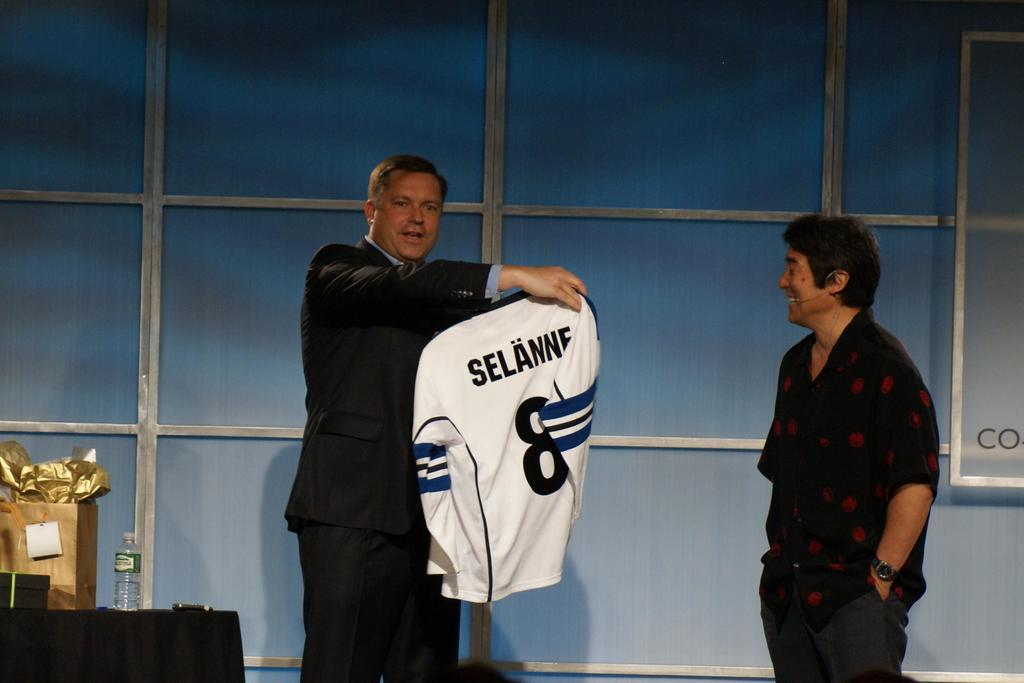Provide a one-sentence caption for the provided image. a very nice jersey that has selanne on the back is nice. 